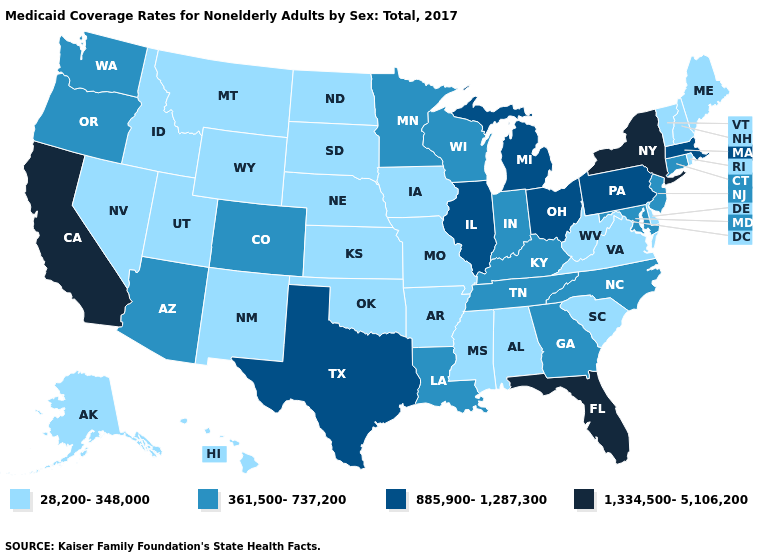Does Kansas have a higher value than Oklahoma?
Quick response, please. No. Does Alabama have the highest value in the USA?
Concise answer only. No. Is the legend a continuous bar?
Keep it brief. No. Does the map have missing data?
Quick response, please. No. What is the lowest value in the USA?
Write a very short answer. 28,200-348,000. What is the value of Michigan?
Give a very brief answer. 885,900-1,287,300. Among the states that border Delaware , which have the lowest value?
Give a very brief answer. Maryland, New Jersey. Name the states that have a value in the range 28,200-348,000?
Concise answer only. Alabama, Alaska, Arkansas, Delaware, Hawaii, Idaho, Iowa, Kansas, Maine, Mississippi, Missouri, Montana, Nebraska, Nevada, New Hampshire, New Mexico, North Dakota, Oklahoma, Rhode Island, South Carolina, South Dakota, Utah, Vermont, Virginia, West Virginia, Wyoming. Name the states that have a value in the range 28,200-348,000?
Be succinct. Alabama, Alaska, Arkansas, Delaware, Hawaii, Idaho, Iowa, Kansas, Maine, Mississippi, Missouri, Montana, Nebraska, Nevada, New Hampshire, New Mexico, North Dakota, Oklahoma, Rhode Island, South Carolina, South Dakota, Utah, Vermont, Virginia, West Virginia, Wyoming. Does Wyoming have the highest value in the West?
Quick response, please. No. Does Minnesota have a higher value than South Carolina?
Give a very brief answer. Yes. What is the value of Kentucky?
Short answer required. 361,500-737,200. Among the states that border Michigan , which have the lowest value?
Be succinct. Indiana, Wisconsin. What is the value of Maine?
Write a very short answer. 28,200-348,000. Among the states that border Missouri , does Illinois have the highest value?
Keep it brief. Yes. 